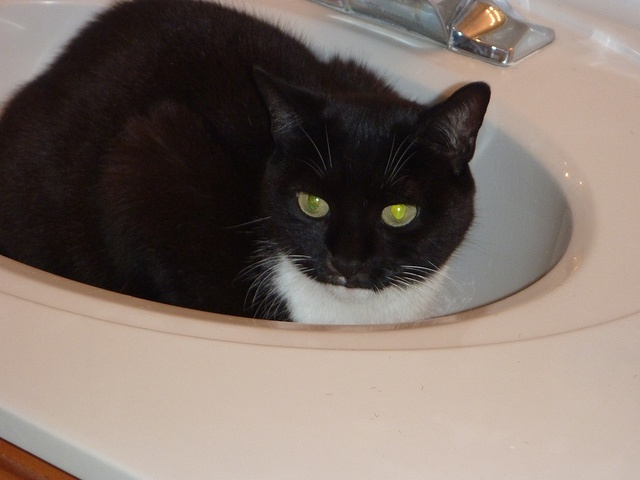Describe the objects in this image and their specific colors. I can see sink in darkgray, tan, lightgray, and gray tones and cat in darkgray, black, and gray tones in this image. 